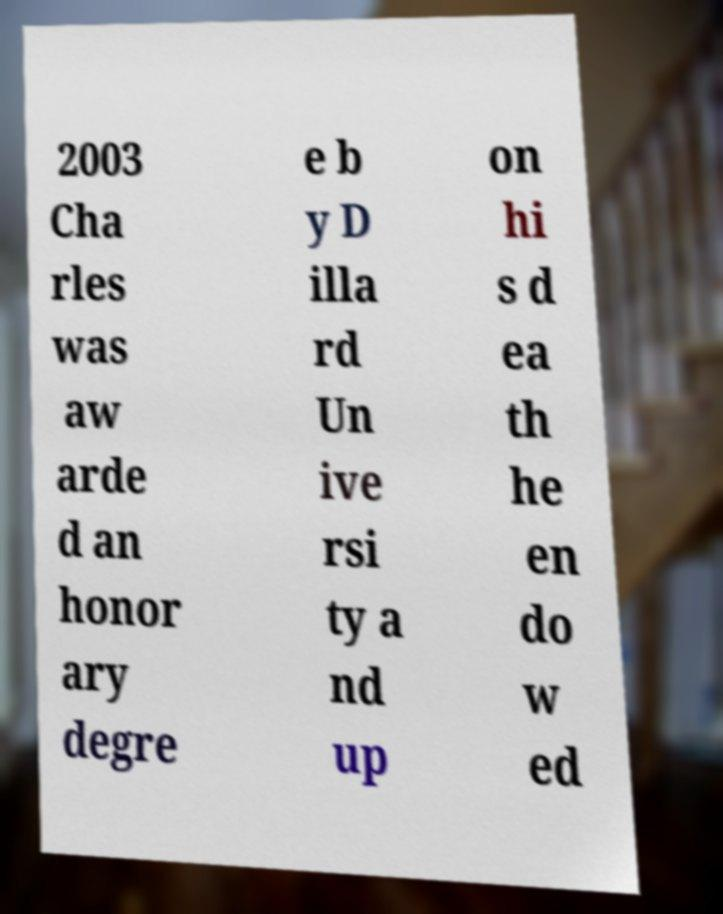Can you read and provide the text displayed in the image?This photo seems to have some interesting text. Can you extract and type it out for me? 2003 Cha rles was aw arde d an honor ary degre e b y D illa rd Un ive rsi ty a nd up on hi s d ea th he en do w ed 